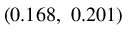<formula> <loc_0><loc_0><loc_500><loc_500>( 0 . 1 6 8 , \ 0 . 2 0 1 )</formula> 